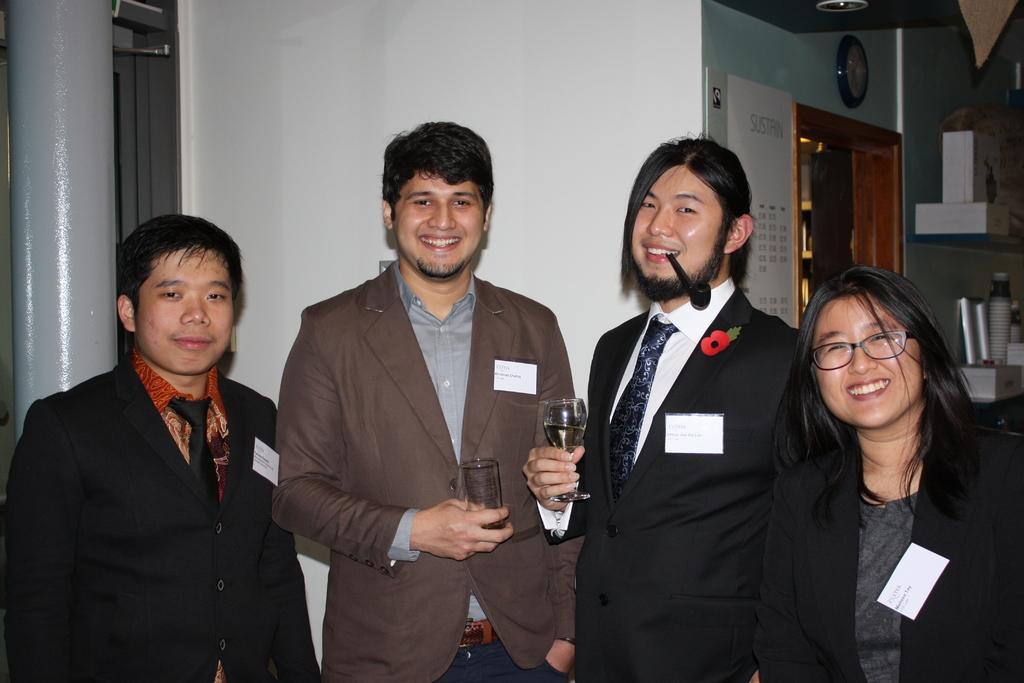Describe this image in one or two sentences. This is the picture of a room. In this image there are group of people standing and smiling and in the middle there are two persons holding the glasses. At the back there is a clock and calendar on the wall. There is a door and there are cups and box in the cupboard. At the top there is a light. 